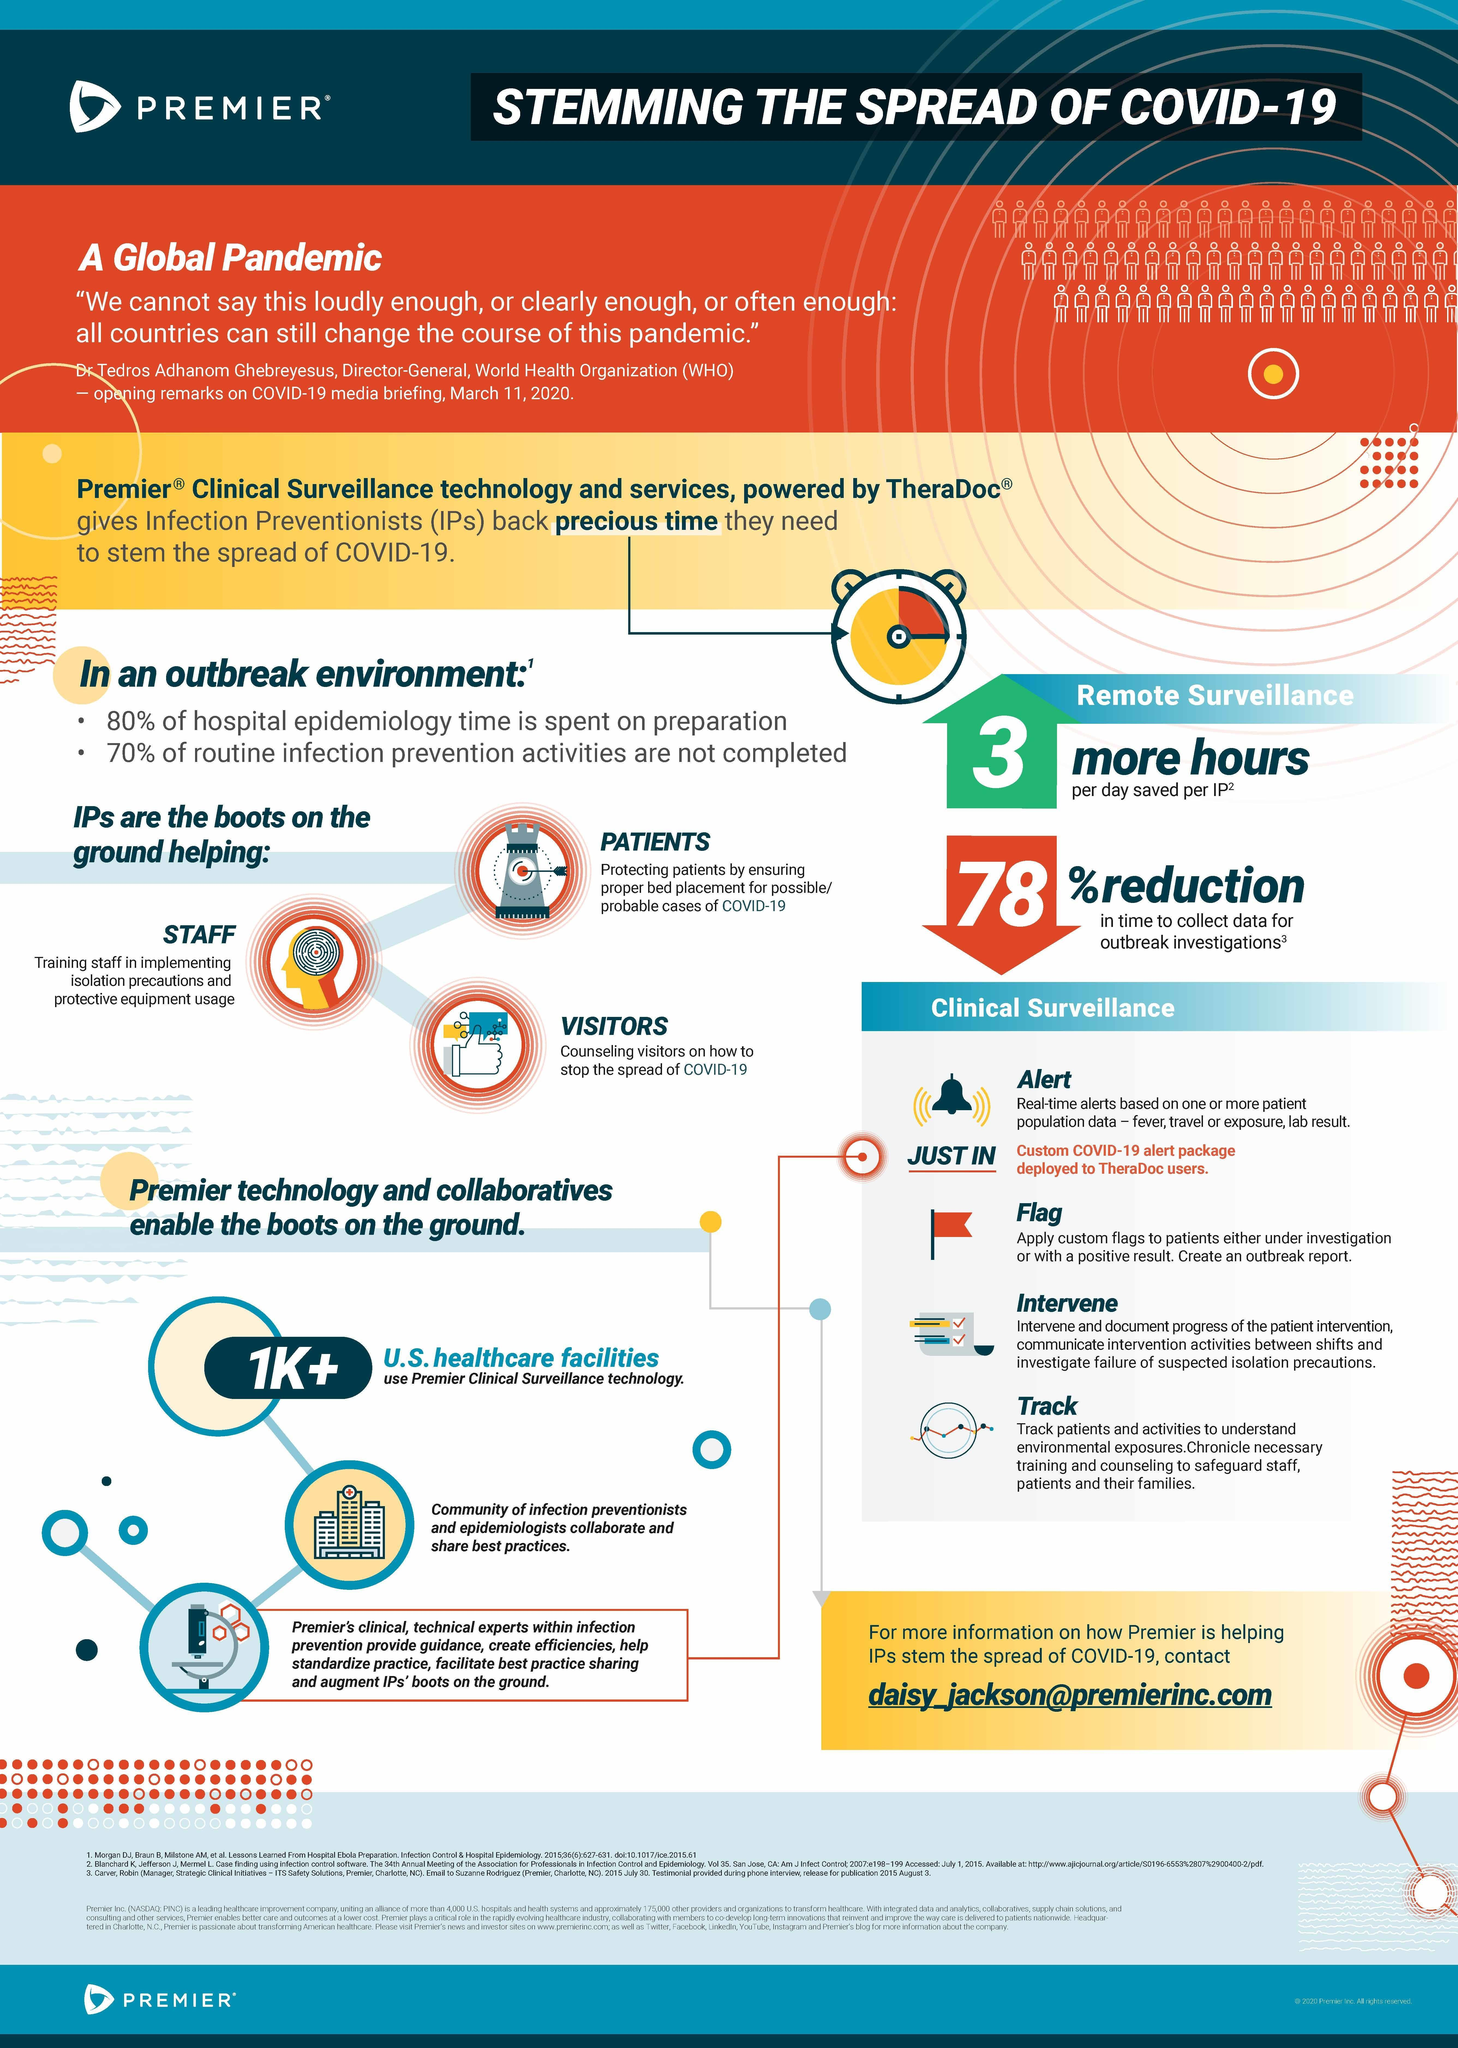How many U.S. healthcare facilities use Premier Clinical Surveillance Technology?
Answer the question with a short phrase. 1K+ 